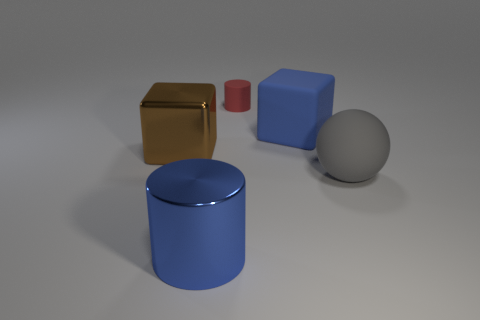Add 5 small red metallic objects. How many objects exist? 10 Subtract all blue cylinders. How many brown cubes are left? 1 Add 4 blue cylinders. How many blue cylinders are left? 5 Add 3 large brown metal cubes. How many large brown metal cubes exist? 4 Subtract 0 yellow blocks. How many objects are left? 5 Subtract all cylinders. How many objects are left? 3 Subtract 1 spheres. How many spheres are left? 0 Subtract all cyan cylinders. Subtract all purple cubes. How many cylinders are left? 2 Subtract all large brown blocks. Subtract all blue rubber things. How many objects are left? 3 